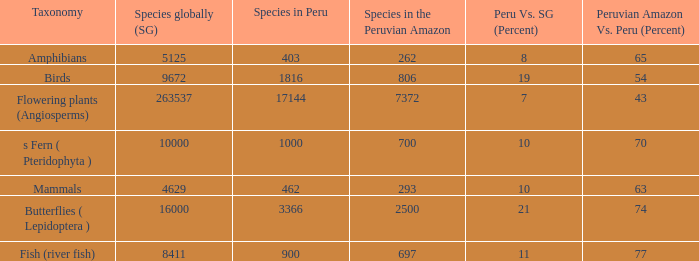Considering 8,411 species globally, how many of them can be found in the peruvian amazon? 1.0. 